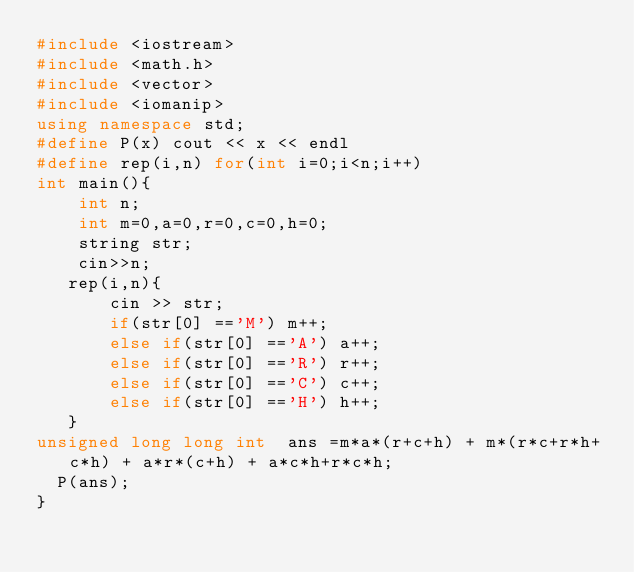Convert code to text. <code><loc_0><loc_0><loc_500><loc_500><_C++_>#include <iostream>
#include <math.h>
#include <vector>
#include <iomanip>
using namespace std;
#define P(x) cout << x << endl
#define rep(i,n) for(int i=0;i<n;i++)
int main(){
    int n;
    int m=0,a=0,r=0,c=0,h=0;
    string str;
    cin>>n;
   rep(i,n){
       cin >> str;
       if(str[0] =='M') m++;
       else if(str[0] =='A') a++;
       else if(str[0] =='R') r++;
       else if(str[0] =='C') c++;
       else if(str[0] =='H') h++;
   }
unsigned long long int  ans =m*a*(r+c+h) + m*(r*c+r*h+c*h) + a*r*(c+h) + a*c*h+r*c*h;
  P(ans);
}
</code> 